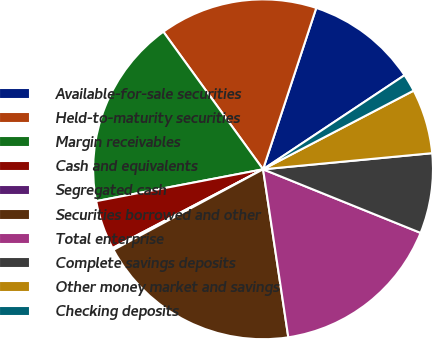Convert chart. <chart><loc_0><loc_0><loc_500><loc_500><pie_chart><fcel>Available-for-sale securities<fcel>Held-to-maturity securities<fcel>Margin receivables<fcel>Cash and equivalents<fcel>Segregated cash<fcel>Securities borrowed and other<fcel>Total enterprise<fcel>Complete savings deposits<fcel>Other money market and savings<fcel>Checking deposits<nl><fcel>10.59%<fcel>15.05%<fcel>18.02%<fcel>4.67%<fcel>0.19%<fcel>19.51%<fcel>16.52%<fcel>7.62%<fcel>6.15%<fcel>1.68%<nl></chart> 